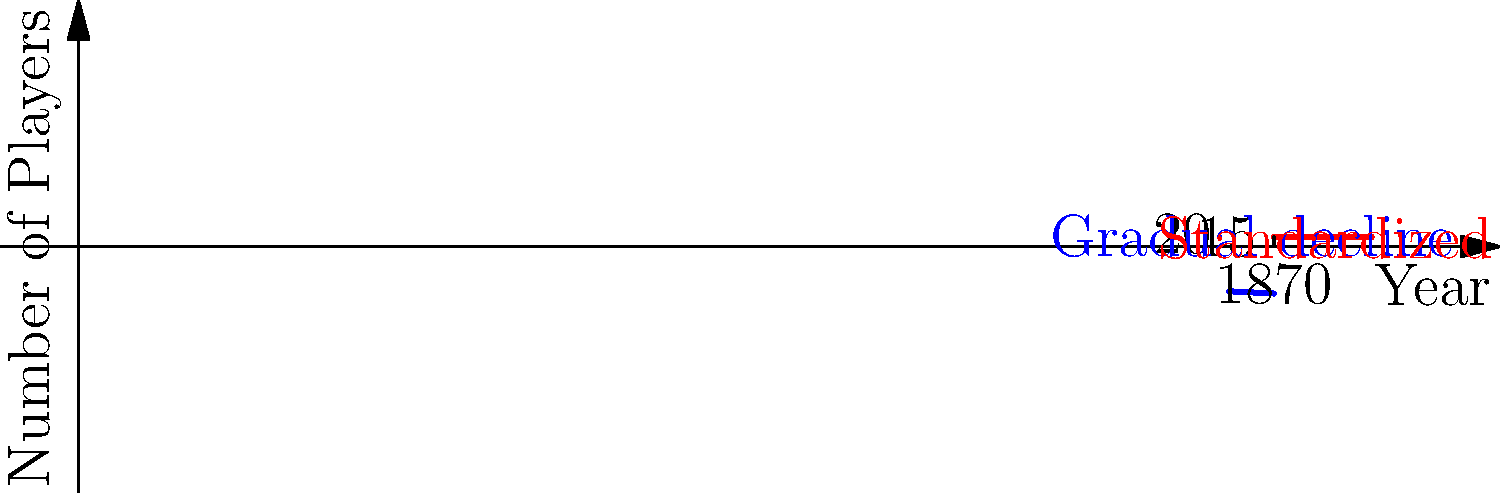The graph shows the change in the number of players in Scottish rugby team formations from 1800 to present. Which year marks the transition to the standardized 15-player formation, and what was the approximate number of players before this transition began? To answer this question, we need to analyze the graph carefully:

1. The graph shows two distinct periods:
   a) A blue line from 1800 to 1870, showing a gradual decline in the number of players.
   b) A red line from 1870 onwards, showing a constant number of players.

2. The transition point between these two periods is clearly marked at 1870.

3. The red line, representing the standardized formation, is labeled "15" on the y-axis, indicating 15 players.

4. Before the transition began:
   a) The blue line starts at 20 players in 1800.
   b) It gradually declines until it reaches 15 players in 1870.

5. The question asks for the approximate number of players before the transition began, which would be the starting point of the blue line in 1800.

Therefore, the year marking the transition to the standardized 15-player formation is 1870, and the approximate number of players before this transition began was 20.
Answer: 1870; 20 players 